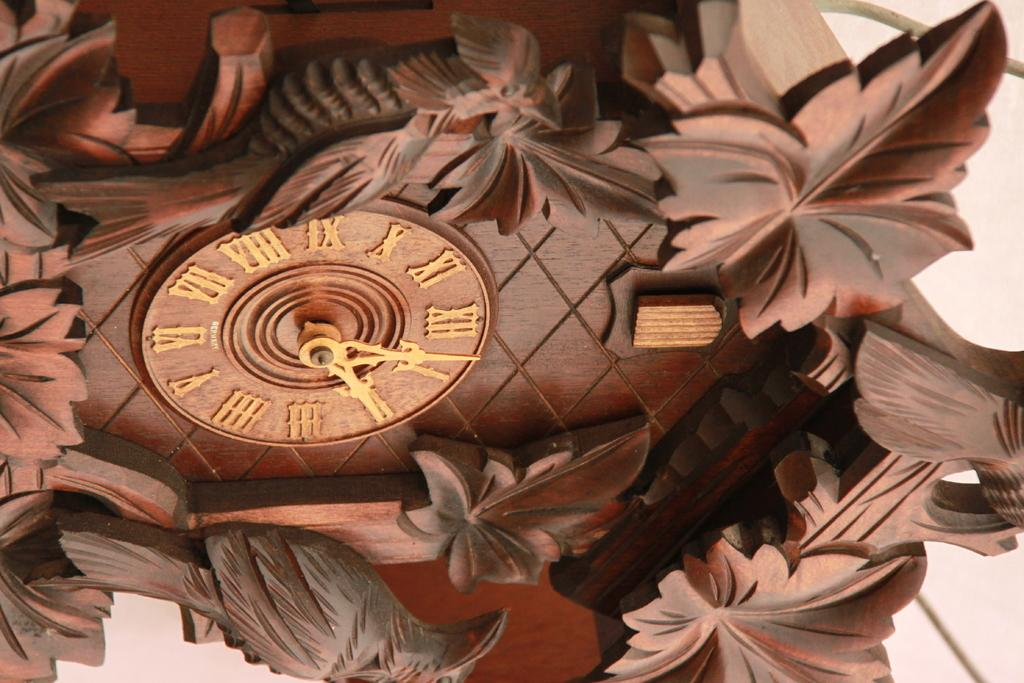<image>
Give a short and clear explanation of the subsequent image. A beautifully carved wooden clock shows the time is a little after 2:00. 